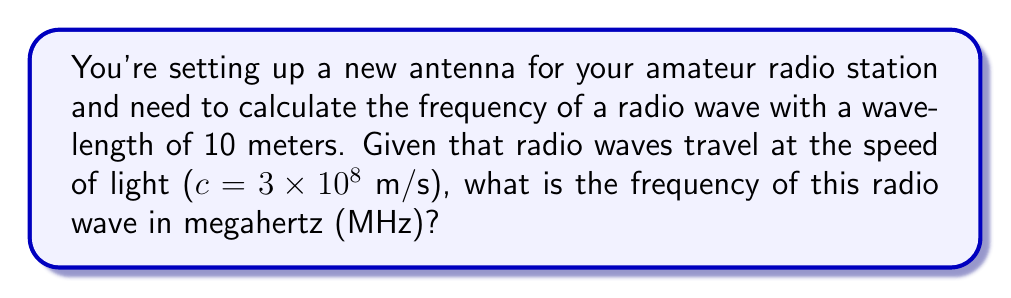Give your solution to this math problem. To solve this problem, we'll use the fundamental relationship between wavelength, frequency, and the speed of light:

$$c = f \lambda$$

Where:
$c$ = speed of light (m/s)
$f$ = frequency (Hz)
$\lambda$ = wavelength (m)

We know:
$c = 3 \times 10^8$ m/s
$\lambda = 10$ m

Let's solve for $f$:

$$f = \frac{c}{\lambda}$$

Substituting the known values:

$$f = \frac{3 \times 10^8 \text{ m/s}}{10 \text{ m}}$$

$$f = 3 \times 10^7 \text{ Hz}$$

To convert Hz to MHz, we divide by $10^6$:

$$f = \frac{3 \times 10^7}{10^6} \text{ MHz}$$

$$f = 30 \text{ MHz}$$
Answer: 30 MHz 